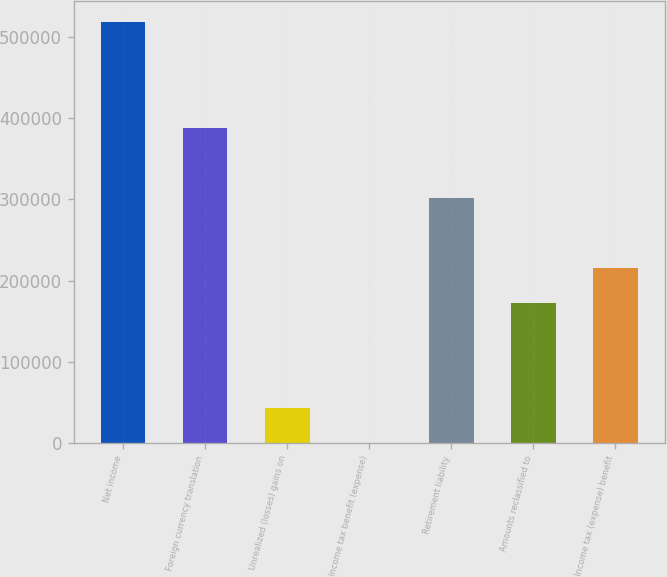Convert chart to OTSL. <chart><loc_0><loc_0><loc_500><loc_500><bar_chart><fcel>Net income<fcel>Foreign currency translation<fcel>Unrealized (losses) gains on<fcel>Income tax benefit (expense)<fcel>Retirement liability<fcel>Amounts reclassified to<fcel>Income tax (expense) benefit<nl><fcel>517935<fcel>388462<fcel>43200.7<fcel>43<fcel>302147<fcel>172674<fcel>215832<nl></chart> 